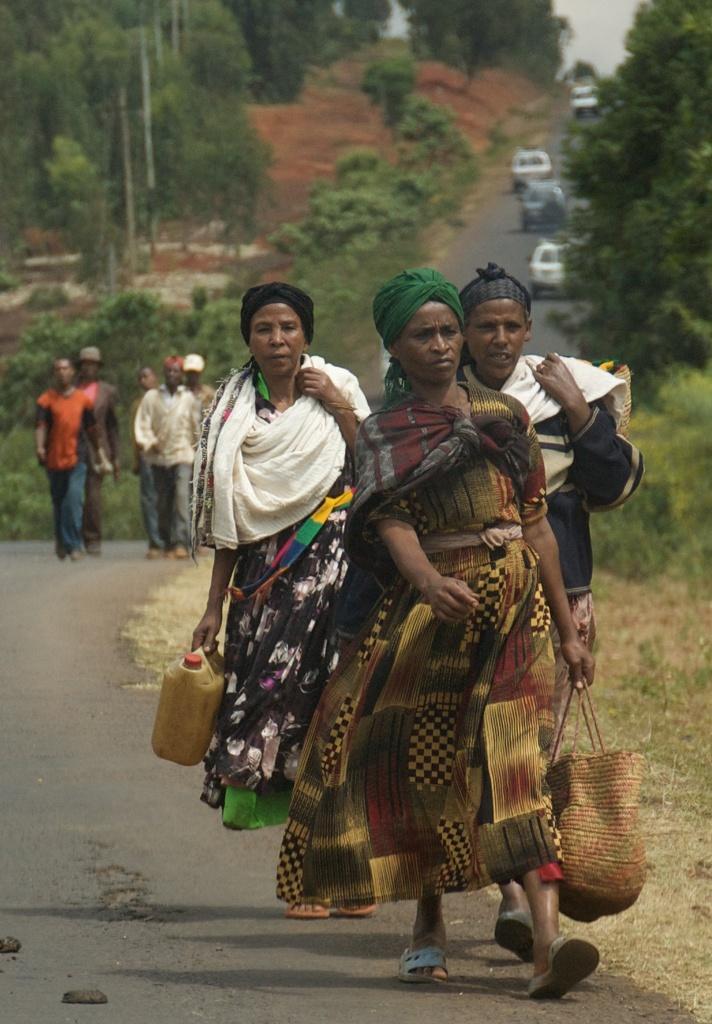Describe this image in one or two sentences. In the picture I can see a group of people are walking on the road, some of them are holding objects in hands. In the background I can see vehicles on the road, plants, trees and some other objects. 